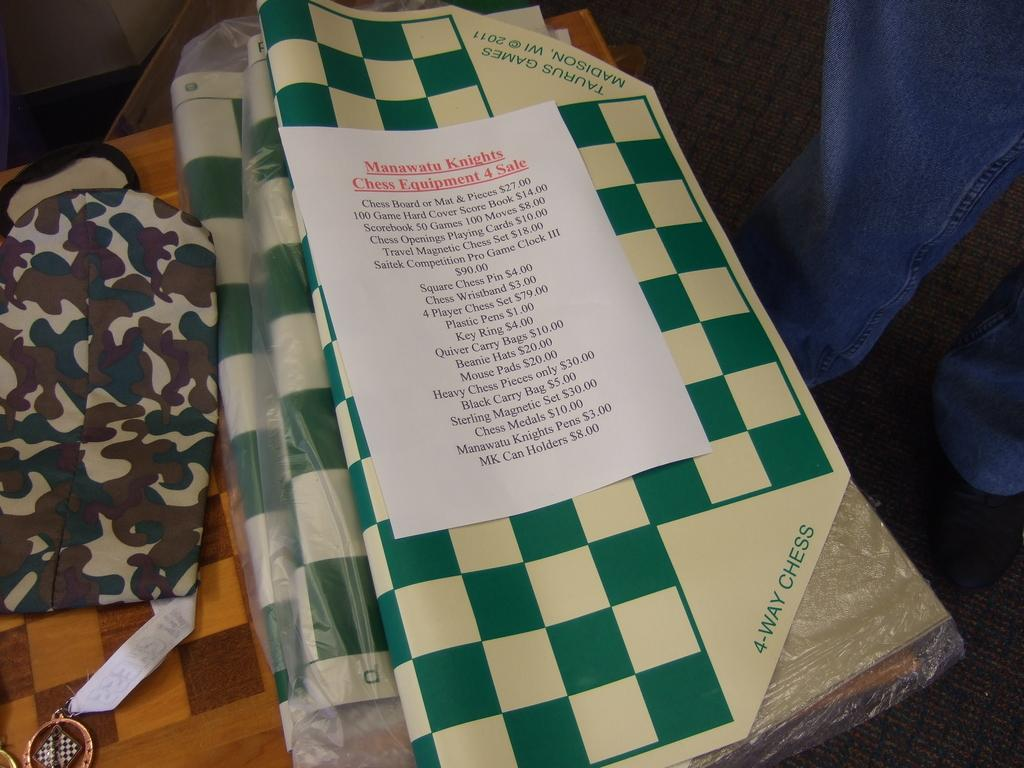What is present on the table in the image? There are objects on the table in the image. Can you describe anything related to a person in the image? The legs of a person are visible at the right side of the image. What type of item with text can be seen in the image? There is a paper with text in the image. What type of star is visible in the image? There is no star visible in the image. What type of voyage is the person taking in the image? There is no indication of a voyage in the image, as only the legs of a person are visible. 